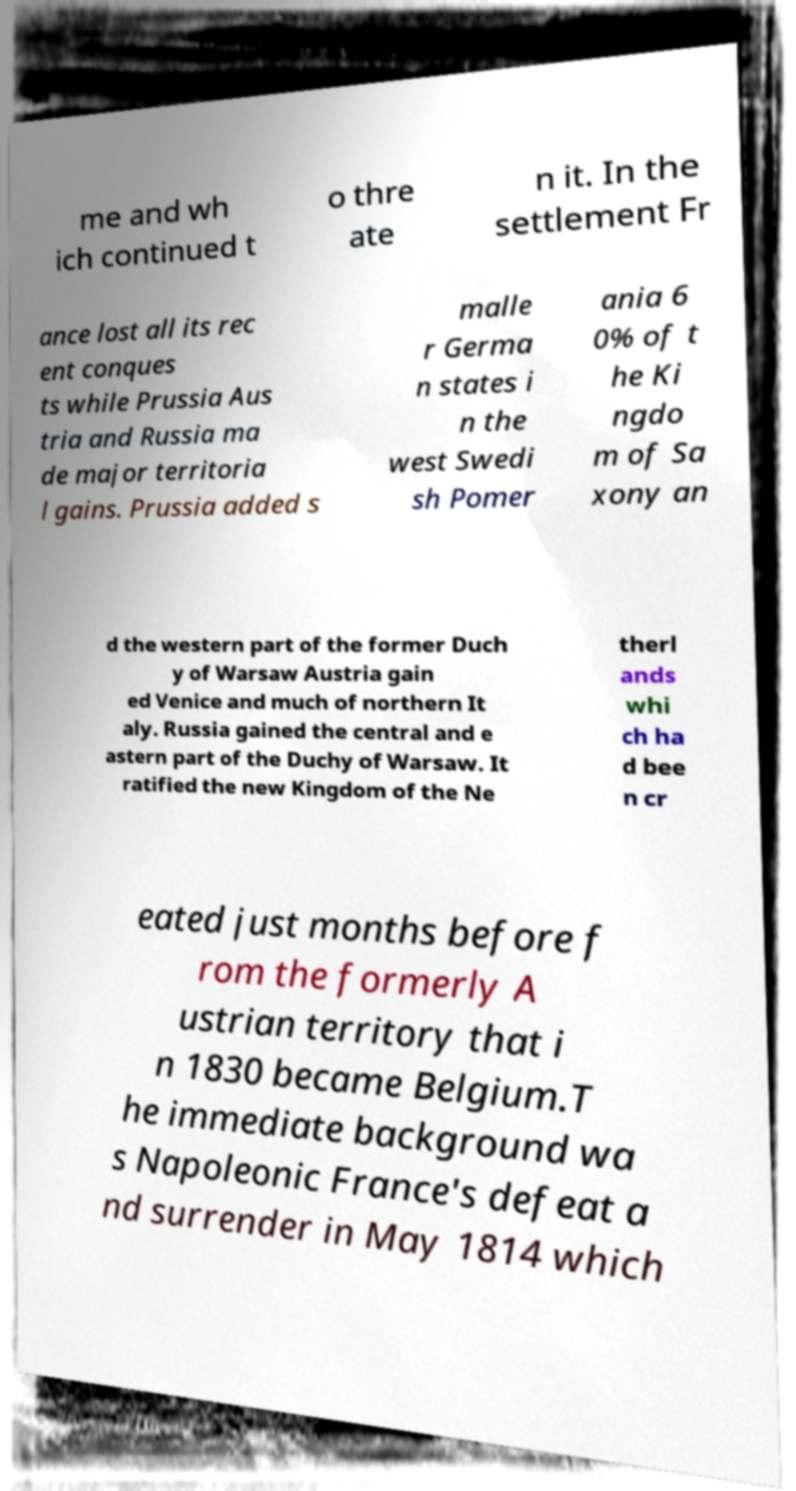Could you extract and type out the text from this image? me and wh ich continued t o thre ate n it. In the settlement Fr ance lost all its rec ent conques ts while Prussia Aus tria and Russia ma de major territoria l gains. Prussia added s malle r Germa n states i n the west Swedi sh Pomer ania 6 0% of t he Ki ngdo m of Sa xony an d the western part of the former Duch y of Warsaw Austria gain ed Venice and much of northern It aly. Russia gained the central and e astern part of the Duchy of Warsaw. It ratified the new Kingdom of the Ne therl ands whi ch ha d bee n cr eated just months before f rom the formerly A ustrian territory that i n 1830 became Belgium.T he immediate background wa s Napoleonic France's defeat a nd surrender in May 1814 which 